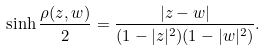Convert formula to latex. <formula><loc_0><loc_0><loc_500><loc_500>\sinh \frac { \rho ( z , w ) } 2 = \frac { | z - w | } { ( 1 - | z | ^ { 2 } ) ( 1 - | w | ^ { 2 } ) } .</formula> 